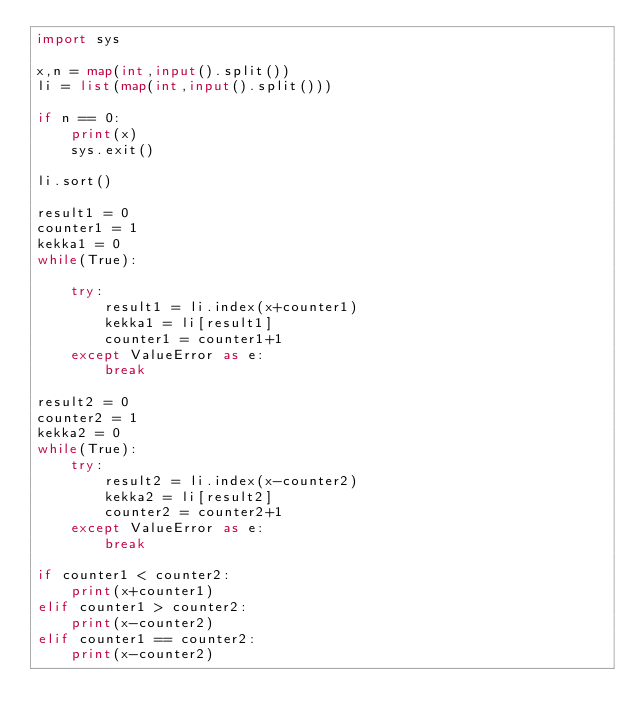Convert code to text. <code><loc_0><loc_0><loc_500><loc_500><_Python_>import sys

x,n = map(int,input().split())
li = list(map(int,input().split()))

if n == 0:
    print(x)
    sys.exit()

li.sort()

result1 = 0
counter1 = 1
kekka1 = 0
while(True):

    try:
        result1 = li.index(x+counter1)
        kekka1 = li[result1]
        counter1 = counter1+1
    except ValueError as e:
        break

result2 = 0
counter2 = 1
kekka2 = 0
while(True):
    try:
        result2 = li.index(x-counter2)
        kekka2 = li[result2]
        counter2 = counter2+1
    except ValueError as e:
        break

if counter1 < counter2:
    print(x+counter1)
elif counter1 > counter2:
    print(x-counter2)
elif counter1 == counter2:
    print(x-counter2)
    

</code> 